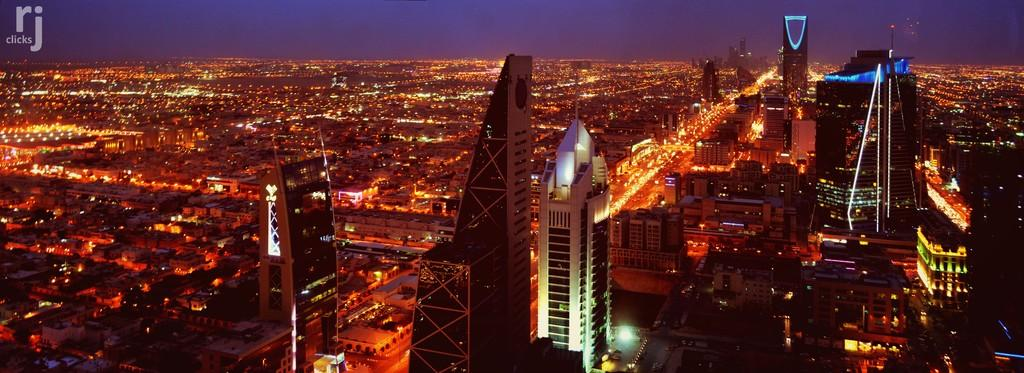What type of view is shown in the image? The image is an aerial view. What types of structures can be seen in the image? There are buildings and homes in the image. What can be seen illuminating the area in the image? There are lights visible in the image. What type of books are being read by the people on the sidewalk in the image? There is no sidewalk or people reading books present in the image. 